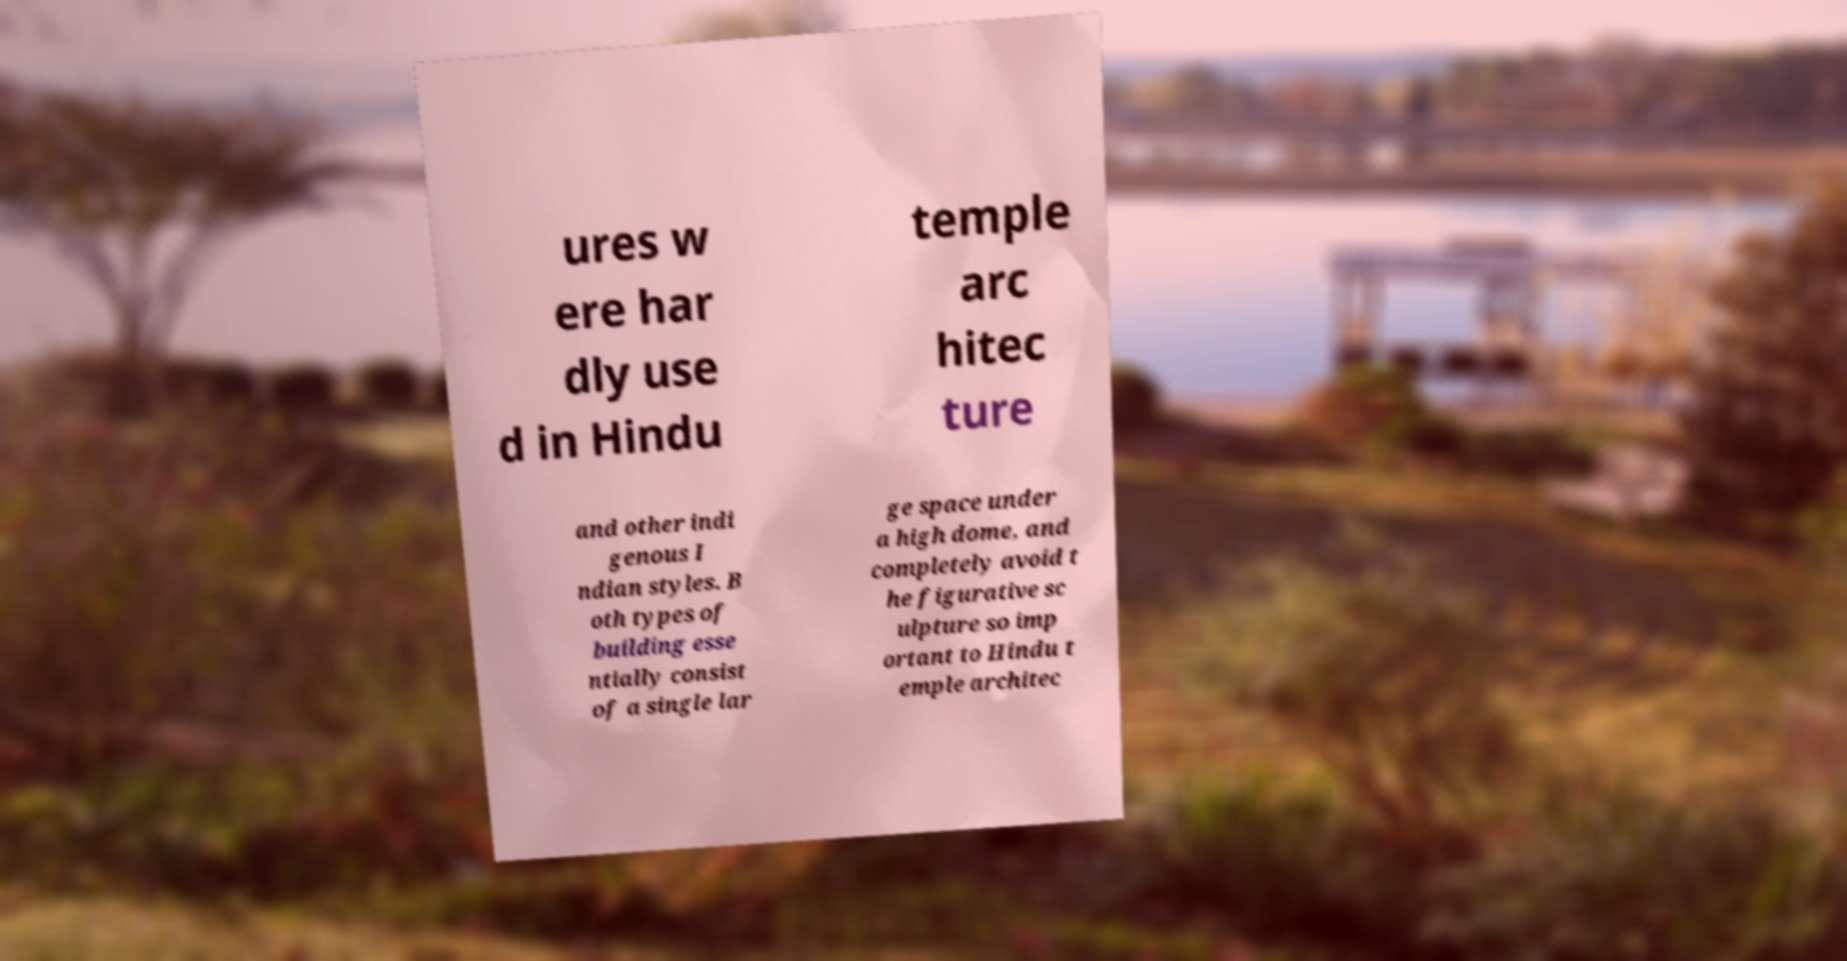There's text embedded in this image that I need extracted. Can you transcribe it verbatim? ures w ere har dly use d in Hindu temple arc hitec ture and other indi genous I ndian styles. B oth types of building esse ntially consist of a single lar ge space under a high dome, and completely avoid t he figurative sc ulpture so imp ortant to Hindu t emple architec 